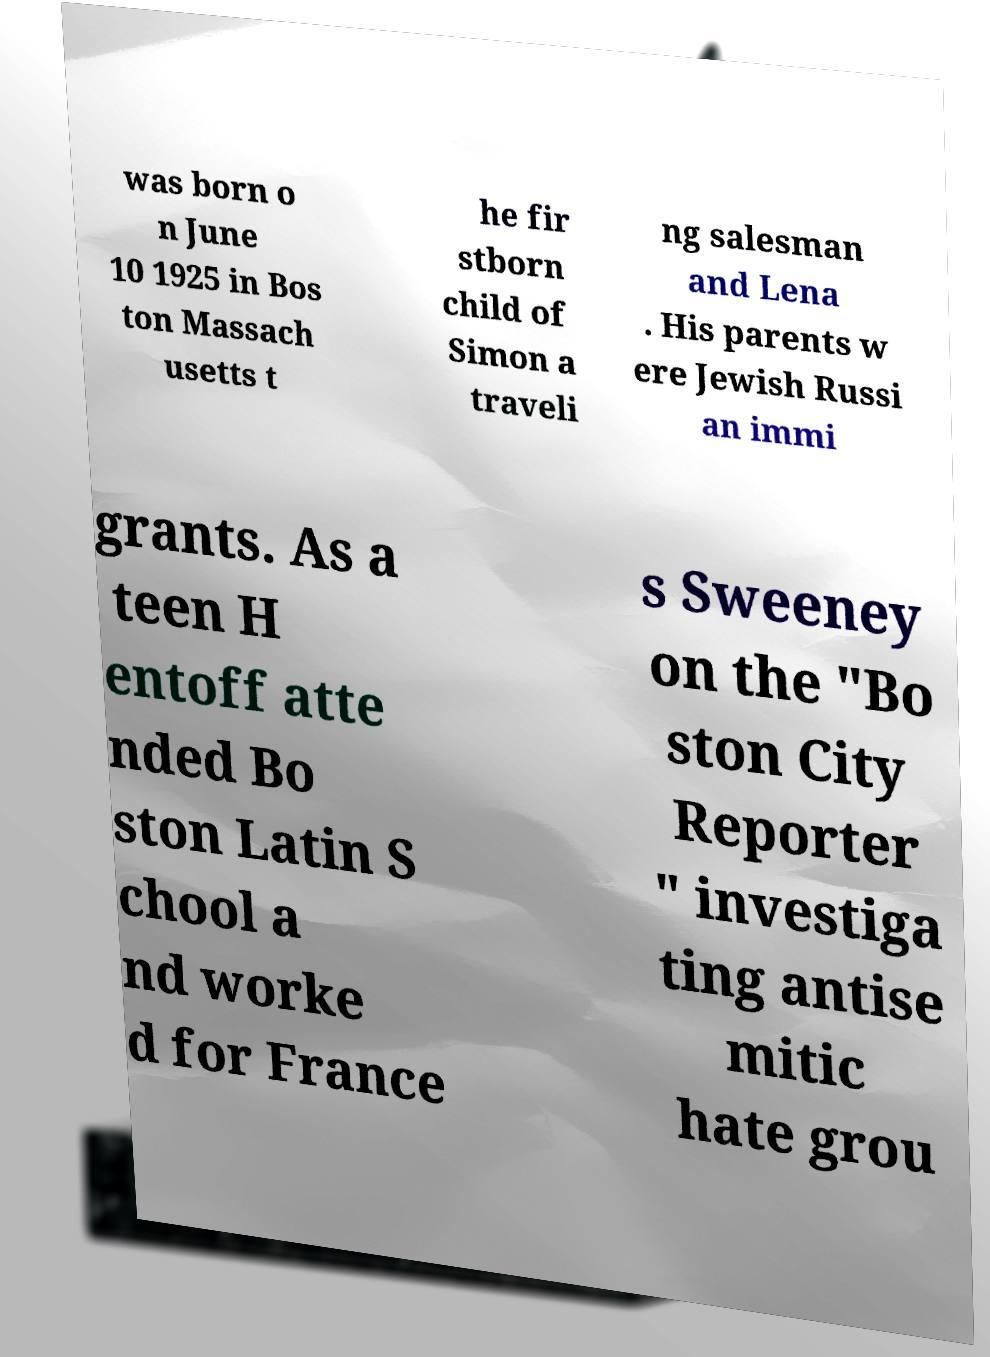Please identify and transcribe the text found in this image. was born o n June 10 1925 in Bos ton Massach usetts t he fir stborn child of Simon a traveli ng salesman and Lena . His parents w ere Jewish Russi an immi grants. As a teen H entoff atte nded Bo ston Latin S chool a nd worke d for France s Sweeney on the "Bo ston City Reporter " investiga ting antise mitic hate grou 